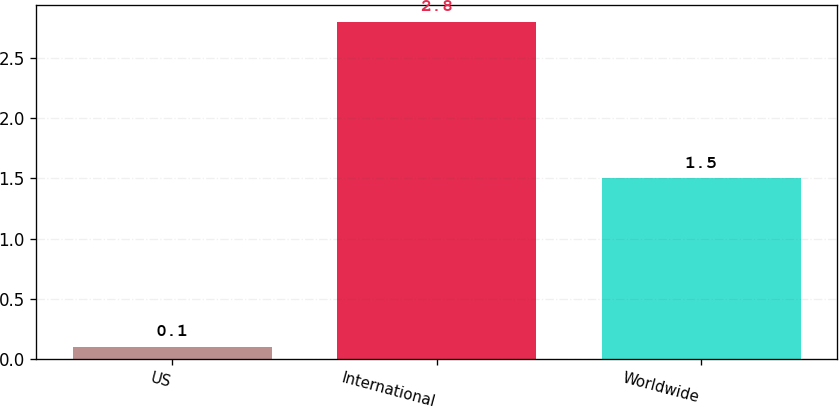Convert chart. <chart><loc_0><loc_0><loc_500><loc_500><bar_chart><fcel>US<fcel>International<fcel>Worldwide<nl><fcel>0.1<fcel>2.8<fcel>1.5<nl></chart> 